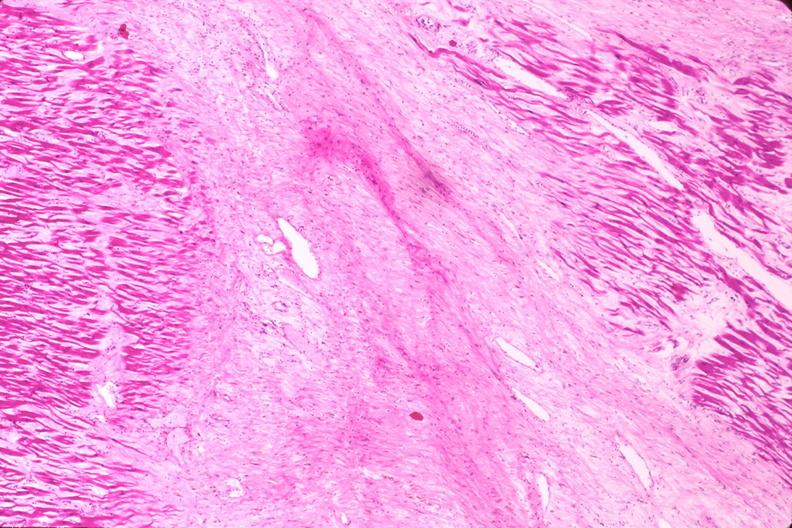does omphalocele show heart, myocardial infarction free wall, 6 days old, in a patient with diabetes mellitus and hypertension?
Answer the question using a single word or phrase. No 